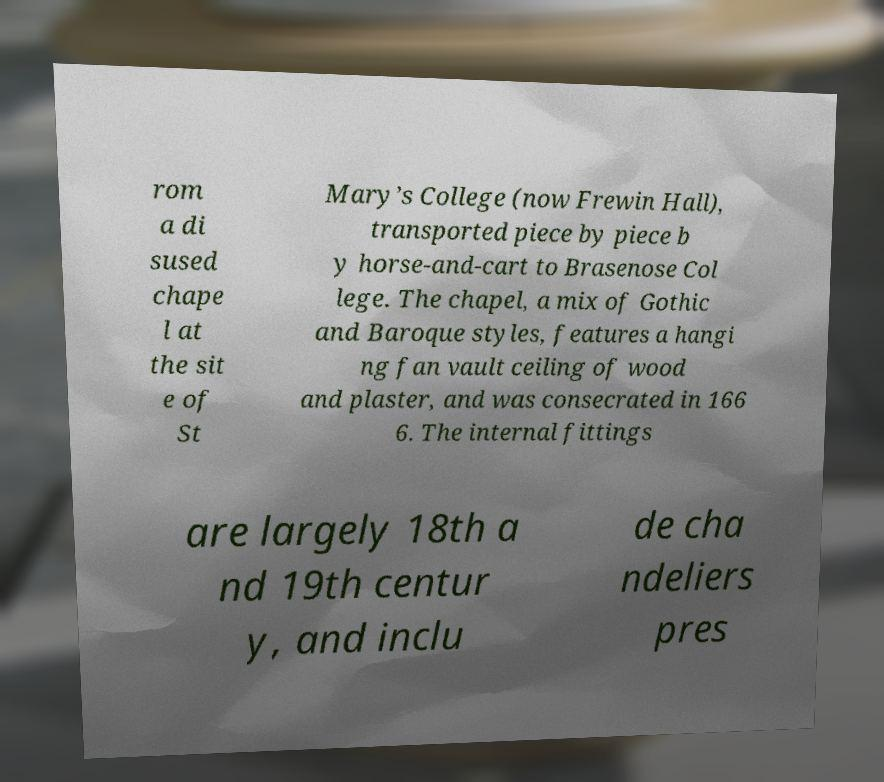Could you extract and type out the text from this image? rom a di sused chape l at the sit e of St Mary’s College (now Frewin Hall), transported piece by piece b y horse-and-cart to Brasenose Col lege. The chapel, a mix of Gothic and Baroque styles, features a hangi ng fan vault ceiling of wood and plaster, and was consecrated in 166 6. The internal fittings are largely 18th a nd 19th centur y, and inclu de cha ndeliers pres 